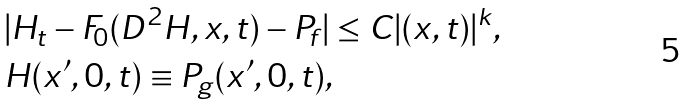Convert formula to latex. <formula><loc_0><loc_0><loc_500><loc_500>& | H _ { t } - F _ { 0 } ( D ^ { 2 } H , x , t ) - P _ { f } | \leq C | ( x , t ) | ^ { k } , \\ & H ( x ^ { \prime } , 0 , t ) \equiv P _ { g } ( x ^ { \prime } , 0 , t ) ,</formula> 